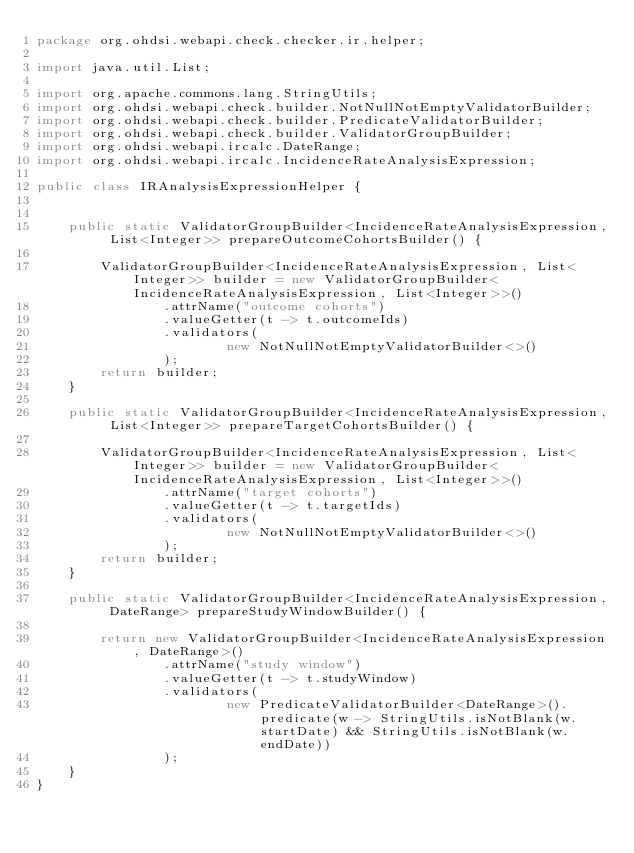Convert code to text. <code><loc_0><loc_0><loc_500><loc_500><_Java_>package org.ohdsi.webapi.check.checker.ir.helper;

import java.util.List;

import org.apache.commons.lang.StringUtils;
import org.ohdsi.webapi.check.builder.NotNullNotEmptyValidatorBuilder;
import org.ohdsi.webapi.check.builder.PredicateValidatorBuilder;
import org.ohdsi.webapi.check.builder.ValidatorGroupBuilder;
import org.ohdsi.webapi.ircalc.DateRange;
import org.ohdsi.webapi.ircalc.IncidenceRateAnalysisExpression;

public class IRAnalysisExpressionHelper {


    public static ValidatorGroupBuilder<IncidenceRateAnalysisExpression, List<Integer>> prepareOutcomeCohortsBuilder() {

        ValidatorGroupBuilder<IncidenceRateAnalysisExpression, List<Integer>> builder = new ValidatorGroupBuilder<IncidenceRateAnalysisExpression, List<Integer>>()
                .attrName("outcome cohorts")
                .valueGetter(t -> t.outcomeIds)
                .validators(
                        new NotNullNotEmptyValidatorBuilder<>()
                );
        return builder;
    }

    public static ValidatorGroupBuilder<IncidenceRateAnalysisExpression, List<Integer>> prepareTargetCohortsBuilder() {

        ValidatorGroupBuilder<IncidenceRateAnalysisExpression, List<Integer>> builder = new ValidatorGroupBuilder<IncidenceRateAnalysisExpression, List<Integer>>()
                .attrName("target cohorts")
                .valueGetter(t -> t.targetIds)
                .validators(
                        new NotNullNotEmptyValidatorBuilder<>()
                );
        return builder;
    }

    public static ValidatorGroupBuilder<IncidenceRateAnalysisExpression, DateRange> prepareStudyWindowBuilder() {

        return new ValidatorGroupBuilder<IncidenceRateAnalysisExpression, DateRange>()
                .attrName("study window")
                .valueGetter(t -> t.studyWindow)
                .validators(
                        new PredicateValidatorBuilder<DateRange>().predicate(w -> StringUtils.isNotBlank(w.startDate) && StringUtils.isNotBlank(w.endDate))
                );
    }
}
</code> 